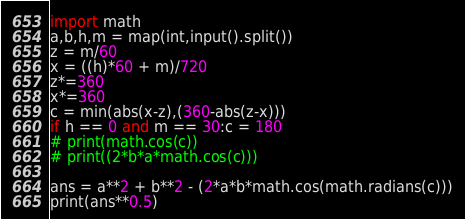<code> <loc_0><loc_0><loc_500><loc_500><_Python_>import math
a,b,h,m = map(int,input().split())
z = m/60
x = ((h)*60 + m)/720
z*=360
x*=360
c = min(abs(x-z),(360-abs(z-x)))
if h == 0 and m == 30:c = 180
# print(math.cos(c))
# print((2*b*a*math.cos(c)))

ans = a**2 + b**2 - (2*a*b*math.cos(math.radians(c)))
print(ans**0.5)
</code> 